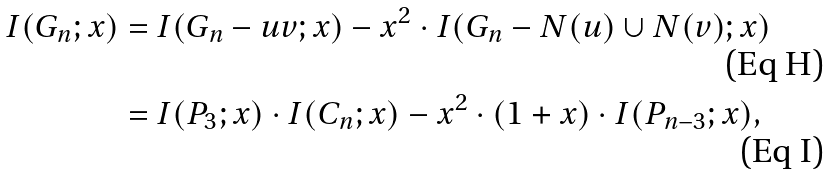Convert formula to latex. <formula><loc_0><loc_0><loc_500><loc_500>I ( G _ { n } ; x ) & = I ( G _ { n } - u v ; x ) - x ^ { 2 } \cdot I ( G _ { n } - N ( u ) \cup N ( v ) ; x ) \\ & = I ( P _ { 3 } ; x ) \cdot I ( C _ { n } ; x ) - x ^ { 2 } \cdot ( 1 + x ) \cdot I ( P _ { n - 3 } ; x ) ,</formula> 